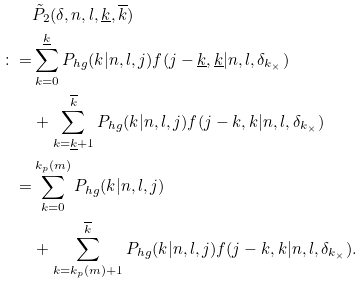<formula> <loc_0><loc_0><loc_500><loc_500>& \tilde { P } _ { 2 } ( \delta , n , l , \underline { k } , \overline { k } ) \\ \colon = & \sum _ { k = 0 } ^ { \underline { k } } P _ { h g } ( k | n , l , j ) f ( j - \underline { k } , \underline { k } | n , l , \delta _ { k _ { \times } } ) \\ & + \sum _ { k = \underline { k } + 1 } ^ { \overline { k } } P _ { h g } ( k | n , l , j ) f ( j - k , k | n , l , \delta _ { k _ { \times } } ) \\ = & \sum _ { k = 0 } ^ { k _ { p } ( m ) } P _ { h g } ( k | n , l , j ) \\ & + \sum _ { k = k _ { p } ( m ) + 1 } ^ { \overline { k } } P _ { h g } ( k | n , l , j ) f ( j - k , k | n , l , \delta _ { k _ { \times } } ) .</formula> 